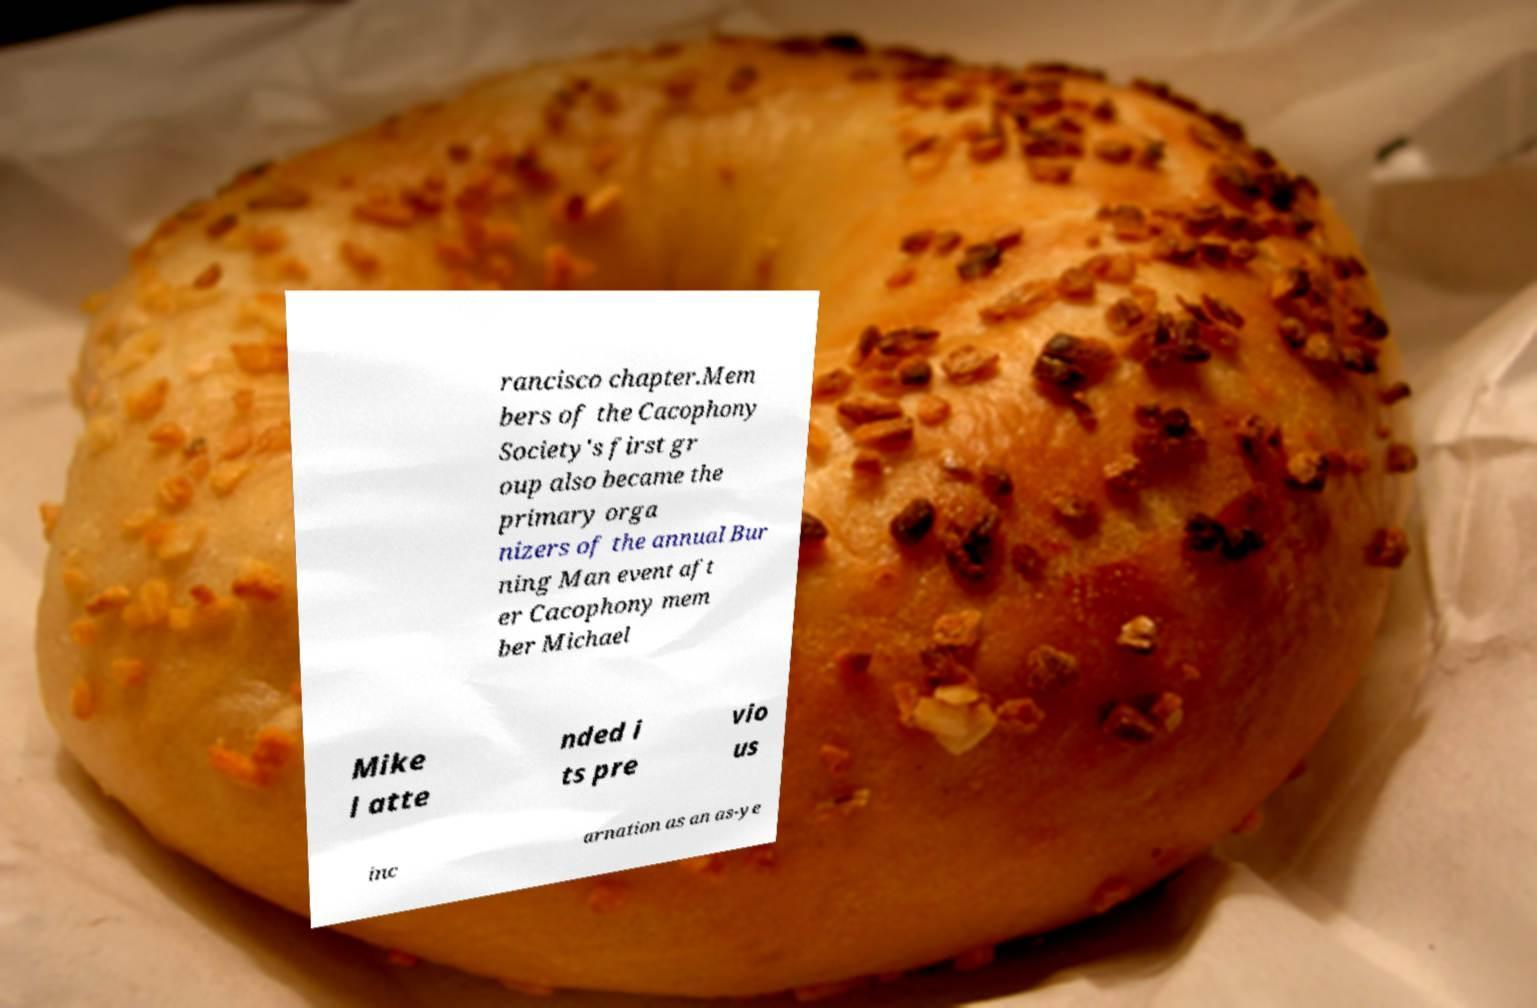Could you assist in decoding the text presented in this image and type it out clearly? rancisco chapter.Mem bers of the Cacophony Society's first gr oup also became the primary orga nizers of the annual Bur ning Man event aft er Cacophony mem ber Michael Mike l atte nded i ts pre vio us inc arnation as an as-ye 